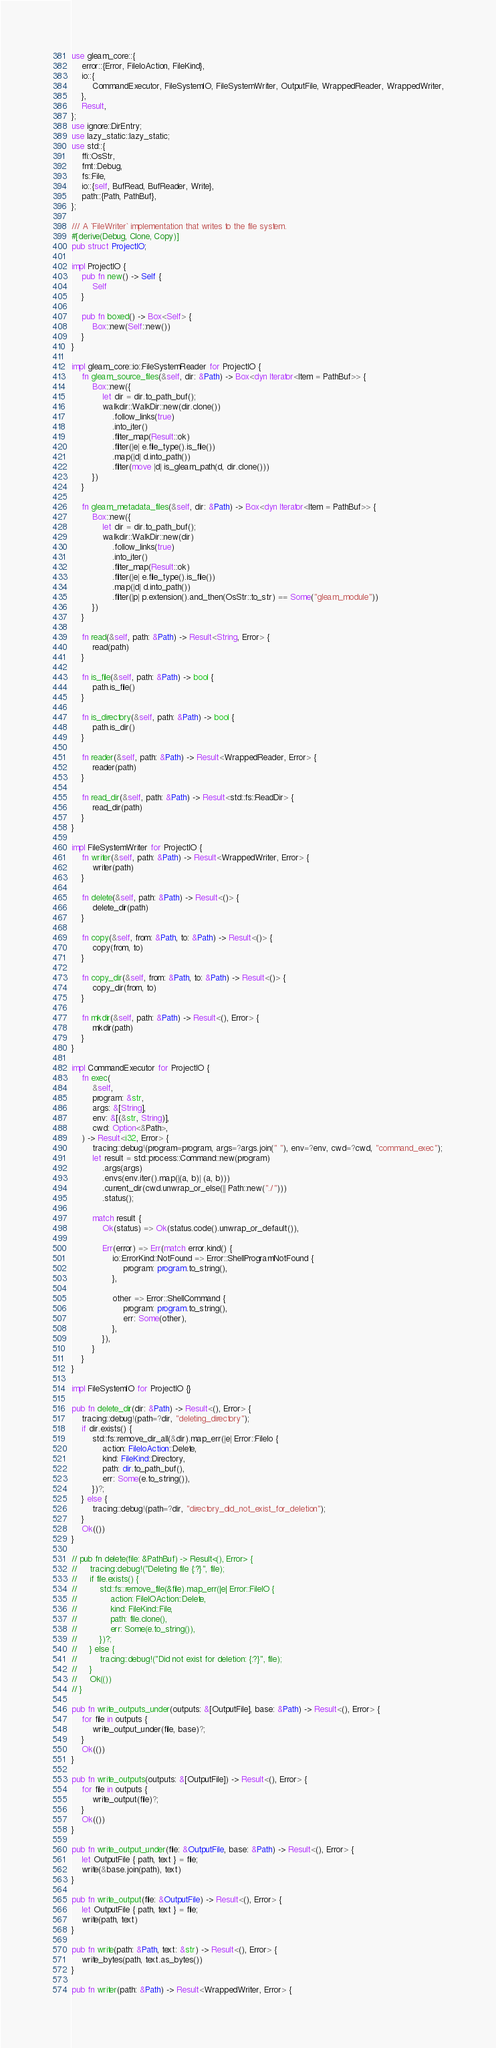<code> <loc_0><loc_0><loc_500><loc_500><_Rust_>use gleam_core::{
    error::{Error, FileIoAction, FileKind},
    io::{
        CommandExecutor, FileSystemIO, FileSystemWriter, OutputFile, WrappedReader, WrappedWriter,
    },
    Result,
};
use ignore::DirEntry;
use lazy_static::lazy_static;
use std::{
    ffi::OsStr,
    fmt::Debug,
    fs::File,
    io::{self, BufRead, BufReader, Write},
    path::{Path, PathBuf},
};

/// A `FileWriter` implementation that writes to the file system.
#[derive(Debug, Clone, Copy)]
pub struct ProjectIO;

impl ProjectIO {
    pub fn new() -> Self {
        Self
    }

    pub fn boxed() -> Box<Self> {
        Box::new(Self::new())
    }
}

impl gleam_core::io::FileSystemReader for ProjectIO {
    fn gleam_source_files(&self, dir: &Path) -> Box<dyn Iterator<Item = PathBuf>> {
        Box::new({
            let dir = dir.to_path_buf();
            walkdir::WalkDir::new(dir.clone())
                .follow_links(true)
                .into_iter()
                .filter_map(Result::ok)
                .filter(|e| e.file_type().is_file())
                .map(|d| d.into_path())
                .filter(move |d| is_gleam_path(d, dir.clone()))
        })
    }

    fn gleam_metadata_files(&self, dir: &Path) -> Box<dyn Iterator<Item = PathBuf>> {
        Box::new({
            let dir = dir.to_path_buf();
            walkdir::WalkDir::new(dir)
                .follow_links(true)
                .into_iter()
                .filter_map(Result::ok)
                .filter(|e| e.file_type().is_file())
                .map(|d| d.into_path())
                .filter(|p| p.extension().and_then(OsStr::to_str) == Some("gleam_module"))
        })
    }

    fn read(&self, path: &Path) -> Result<String, Error> {
        read(path)
    }

    fn is_file(&self, path: &Path) -> bool {
        path.is_file()
    }

    fn is_directory(&self, path: &Path) -> bool {
        path.is_dir()
    }

    fn reader(&self, path: &Path) -> Result<WrappedReader, Error> {
        reader(path)
    }

    fn read_dir(&self, path: &Path) -> Result<std::fs::ReadDir> {
        read_dir(path)
    }
}

impl FileSystemWriter for ProjectIO {
    fn writer(&self, path: &Path) -> Result<WrappedWriter, Error> {
        writer(path)
    }

    fn delete(&self, path: &Path) -> Result<()> {
        delete_dir(path)
    }

    fn copy(&self, from: &Path, to: &Path) -> Result<()> {
        copy(from, to)
    }

    fn copy_dir(&self, from: &Path, to: &Path) -> Result<()> {
        copy_dir(from, to)
    }

    fn mkdir(&self, path: &Path) -> Result<(), Error> {
        mkdir(path)
    }
}

impl CommandExecutor for ProjectIO {
    fn exec(
        &self,
        program: &str,
        args: &[String],
        env: &[(&str, String)],
        cwd: Option<&Path>,
    ) -> Result<i32, Error> {
        tracing::debug!(program=program, args=?args.join(" "), env=?env, cwd=?cwd, "command_exec");
        let result = std::process::Command::new(program)
            .args(args)
            .envs(env.iter().map(|(a, b)| (a, b)))
            .current_dir(cwd.unwrap_or_else(|| Path::new("./")))
            .status();

        match result {
            Ok(status) => Ok(status.code().unwrap_or_default()),

            Err(error) => Err(match error.kind() {
                io::ErrorKind::NotFound => Error::ShellProgramNotFound {
                    program: program.to_string(),
                },

                other => Error::ShellCommand {
                    program: program.to_string(),
                    err: Some(other),
                },
            }),
        }
    }
}

impl FileSystemIO for ProjectIO {}

pub fn delete_dir(dir: &Path) -> Result<(), Error> {
    tracing::debug!(path=?dir, "deleting_directory");
    if dir.exists() {
        std::fs::remove_dir_all(&dir).map_err(|e| Error::FileIo {
            action: FileIoAction::Delete,
            kind: FileKind::Directory,
            path: dir.to_path_buf(),
            err: Some(e.to_string()),
        })?;
    } else {
        tracing::debug!(path=?dir, "directory_did_not_exist_for_deletion");
    }
    Ok(())
}

// pub fn delete(file: &PathBuf) -> Result<(), Error> {
//     tracing::debug!("Deleting file {:?}", file);
//     if file.exists() {
//         std::fs::remove_file(&file).map_err(|e| Error::FileIO {
//             action: FileIOAction::Delete,
//             kind: FileKind::File,
//             path: file.clone(),
//             err: Some(e.to_string()),
//         })?;
//     } else {
//         tracing::debug!("Did not exist for deletion: {:?}", file);
//     }
//     Ok(())
// }

pub fn write_outputs_under(outputs: &[OutputFile], base: &Path) -> Result<(), Error> {
    for file in outputs {
        write_output_under(file, base)?;
    }
    Ok(())
}

pub fn write_outputs(outputs: &[OutputFile]) -> Result<(), Error> {
    for file in outputs {
        write_output(file)?;
    }
    Ok(())
}

pub fn write_output_under(file: &OutputFile, base: &Path) -> Result<(), Error> {
    let OutputFile { path, text } = file;
    write(&base.join(path), text)
}

pub fn write_output(file: &OutputFile) -> Result<(), Error> {
    let OutputFile { path, text } = file;
    write(path, text)
}

pub fn write(path: &Path, text: &str) -> Result<(), Error> {
    write_bytes(path, text.as_bytes())
}

pub fn writer(path: &Path) -> Result<WrappedWriter, Error> {</code> 